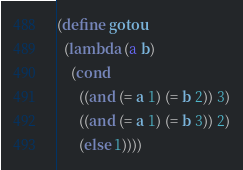Convert code to text. <code><loc_0><loc_0><loc_500><loc_500><_Scheme_>(define gotou
  (lambda (a b)
    (cond
      ((and (= a 1) (= b 2)) 3)
      ((and (= a 1) (= b 3)) 2)
      (else 1))))</code> 